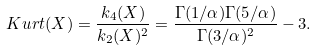Convert formula to latex. <formula><loc_0><loc_0><loc_500><loc_500>K u r t ( X ) = \frac { k _ { 4 } ( X ) } { k _ { 2 } ( X ) ^ { 2 } } = \frac { \Gamma ( 1 / \alpha ) \Gamma ( 5 / \alpha ) } { \Gamma ( 3 / \alpha ) ^ { 2 } } - 3 .</formula> 